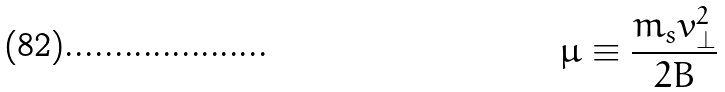<formula> <loc_0><loc_0><loc_500><loc_500>\mu \equiv \frac { m _ { s } v _ { \perp } ^ { 2 } } { 2 B }</formula> 